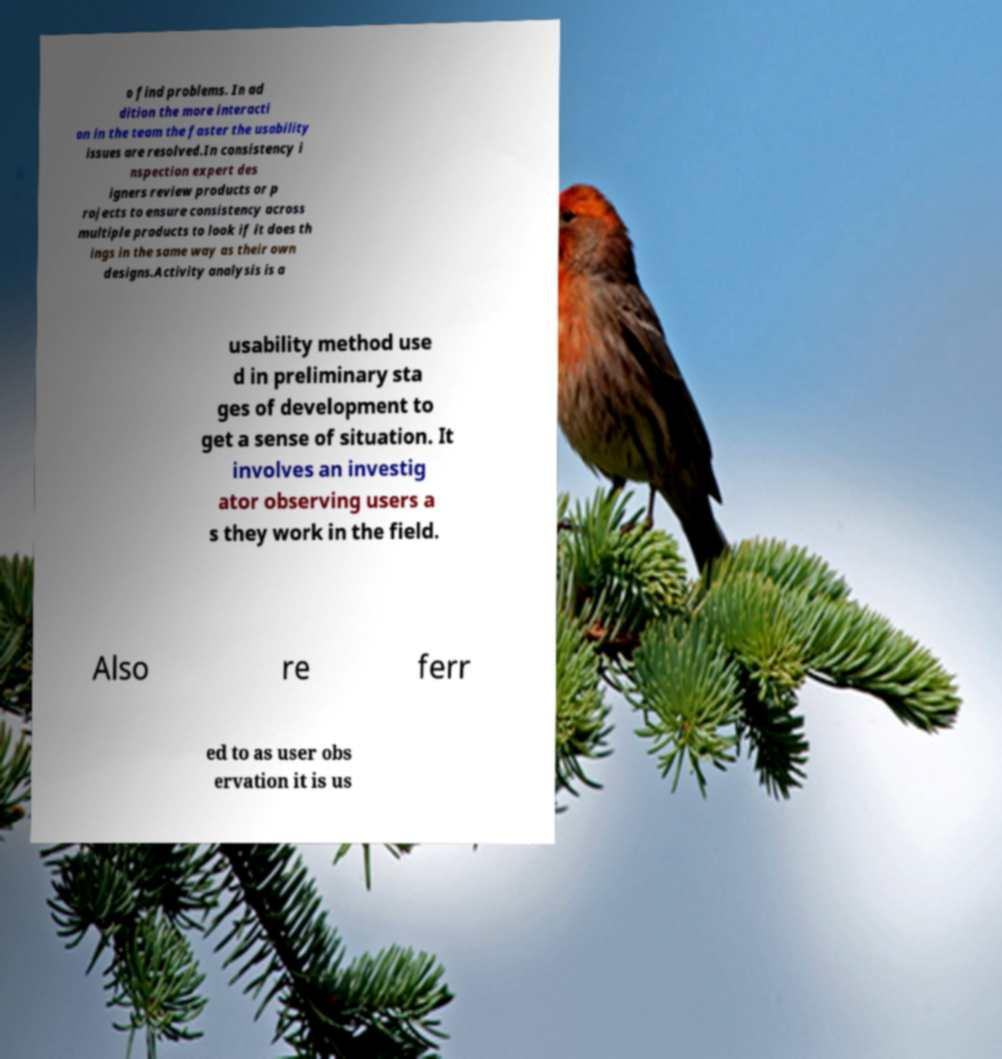What messages or text are displayed in this image? I need them in a readable, typed format. o find problems. In ad dition the more interacti on in the team the faster the usability issues are resolved.In consistency i nspection expert des igners review products or p rojects to ensure consistency across multiple products to look if it does th ings in the same way as their own designs.Activity analysis is a usability method use d in preliminary sta ges of development to get a sense of situation. It involves an investig ator observing users a s they work in the field. Also re ferr ed to as user obs ervation it is us 